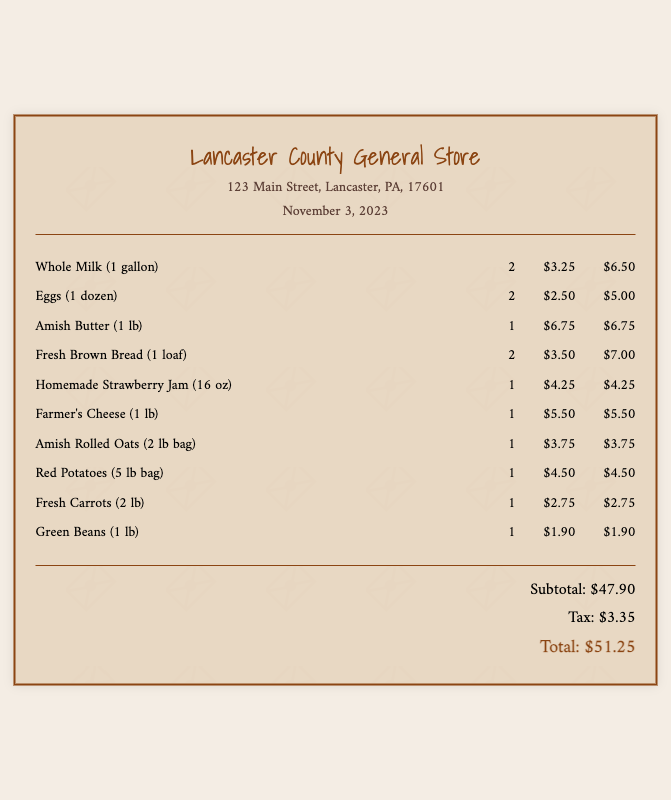What is the total cost of the grocery purchase? The total cost is calculated as the sum of the subtotal and tax in the document. Subtotal is $47.90 and tax is $3.35, so total cost is $47.90 + $3.35 = $51.25.
Answer: $51.25 How many gallons of whole milk were purchased? The number of gallons of whole milk purchased is listed directly in the items section of the document, which specifies 2 gallons of whole milk.
Answer: 2 What is the price of one dozen eggs? The unit price for one dozen eggs is noted in the document, which shows it as $2.50.
Answer: $2.50 Which store's receipt is this? The receipt indicates the store name at the top, which is Lancaster County General Store.
Answer: Lancaster County General Store What is the subtotal before tax? The subtotal is the summation of all item prices before tax, clearly indicated in the document as $47.90.
Answer: $47.90 How many items of farmer's cheese were purchased? The document shows that 1 lb of farmer's cheese was purchased, so the quantity is 1.
Answer: 1 What is the address of the store? The document states the address of the store, which is 123 Main Street, Lancaster, PA, 17601.
Answer: 123 Main Street, Lancaster, PA, 17601 How much tax was applied to the grocery total? The tax is specified directly in the document, and it is $3.35.
Answer: $3.35 What type of bread was purchased? The document lists one item specifically as Fresh Brown Bread.
Answer: Fresh Brown Bread 